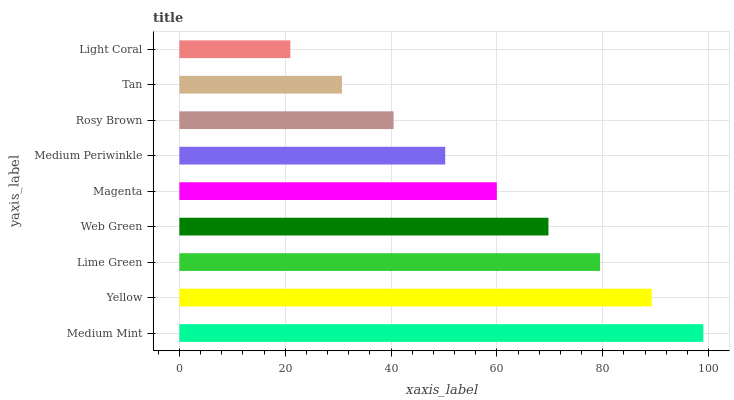Is Light Coral the minimum?
Answer yes or no. Yes. Is Medium Mint the maximum?
Answer yes or no. Yes. Is Yellow the minimum?
Answer yes or no. No. Is Yellow the maximum?
Answer yes or no. No. Is Medium Mint greater than Yellow?
Answer yes or no. Yes. Is Yellow less than Medium Mint?
Answer yes or no. Yes. Is Yellow greater than Medium Mint?
Answer yes or no. No. Is Medium Mint less than Yellow?
Answer yes or no. No. Is Magenta the high median?
Answer yes or no. Yes. Is Magenta the low median?
Answer yes or no. Yes. Is Yellow the high median?
Answer yes or no. No. Is Tan the low median?
Answer yes or no. No. 